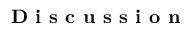<formula> <loc_0><loc_0><loc_500><loc_500>D i s c u s s i o n</formula> 